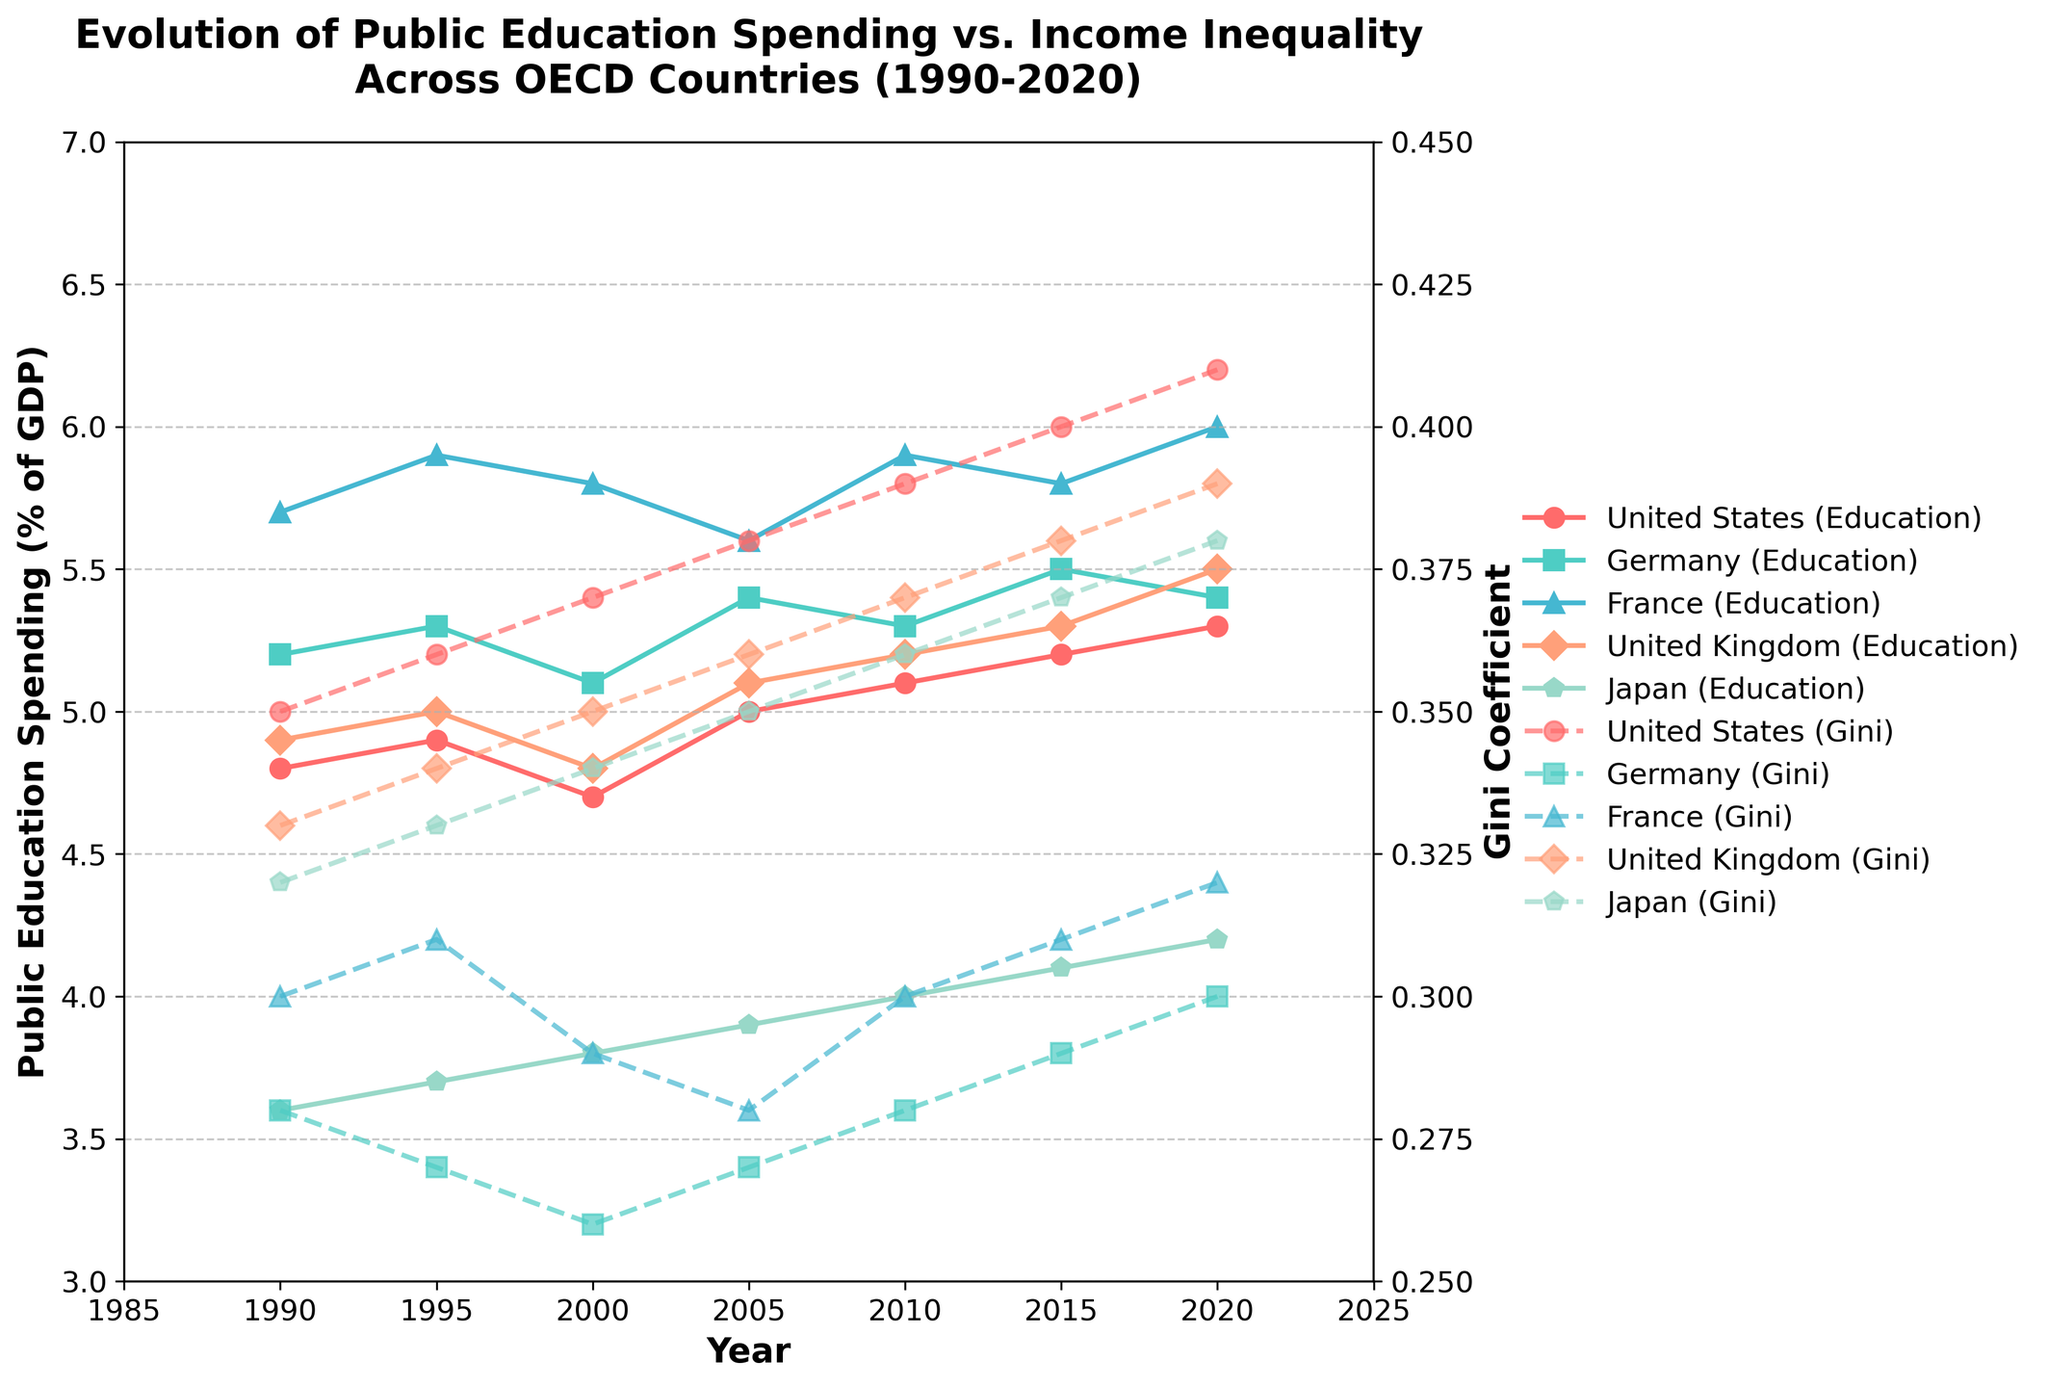What is the title of the plot? The title of the plot is given at the top, describing what the plot represents.
Answer: Evolution of Public Education Spending vs. Income Inequality Across OECD Countries (1990-2020) How many countries are represented in the plot? The legend at the side of the plot lists each country, each with a different color and marker. Counting these gives the number of countries.
Answer: 5 Which country had the highest public education spending in 2020? The plot of Public Education Spending (% of GDP) is on the left y-axis, and we can see that in 2020, the country with the highest point is shown by France.
Answer: France How has the Gini Coefficient for the United States changed from 1990 to 2020? To determine this, follow the dashed line for the United States. It starts around 0.35 in 1990 and ends around 0.41 in 2020.
Answer: Increased How does the public education spending in Japan in 2020 compare with that in 1990? By comparing the solid Japan line in 1990 and 2020, we see that it starts around 3.6% of GDP in 1990 and reaches about 4.2% in 2020.
Answer: Increased Which country shows the most stable (least change) Gini Coefficient over the given period? Look for the country whose dashed line shows the least fluctuation among the years from 1990 to 2020. This is Germany, whose Gini Coefficient remains close to 0.28-0.30.
Answer: Germany Calculate the average public education spending for France from 1990 to 2020. Sum the values for France across the years and divide by the number of data points (6). (5.7 + 5.9 + 5.8 + 5.6 + 5.9 + 6.0) / 6 = 34.9 / 6 ≈ 5.82
Answer: 5.82 Between 1990 and 2020, did any country show a decrease in public education spending? Check the trends of the solid lines for each country across the years, noticing any declines. The United Kingdom's spending slightly decreased from 5.5% in 2020, compared to some previous years, but generally increased over the period.
Answer: No Which country had the highest Gini Coefficient in 2010, and what was its value? Find the country with the highest point on the dotted lines for the Gini Coefficient in 2010. The United States had the highest Gini Coefficient at around 0.39.
Answer: United States, 0.39 